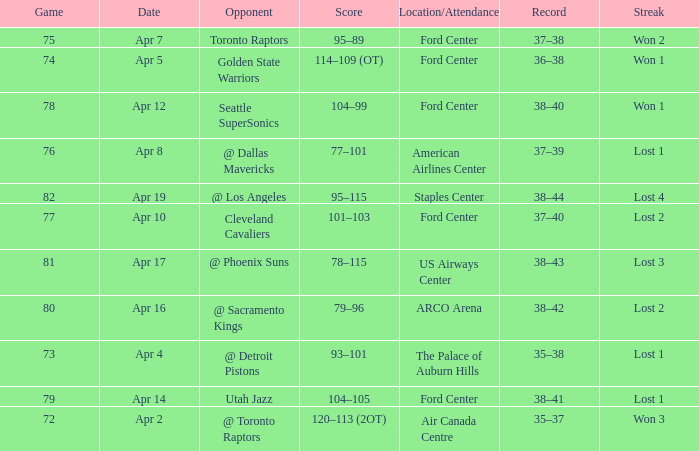What was the record for less than 78 games and a score of 114–109 (ot)? 36–38. 